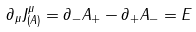Convert formula to latex. <formula><loc_0><loc_0><loc_500><loc_500>\partial _ { \mu } J ^ { \mu } _ { ( A ) } = \partial _ { - } A _ { + } - \partial _ { + } A _ { - } = E</formula> 